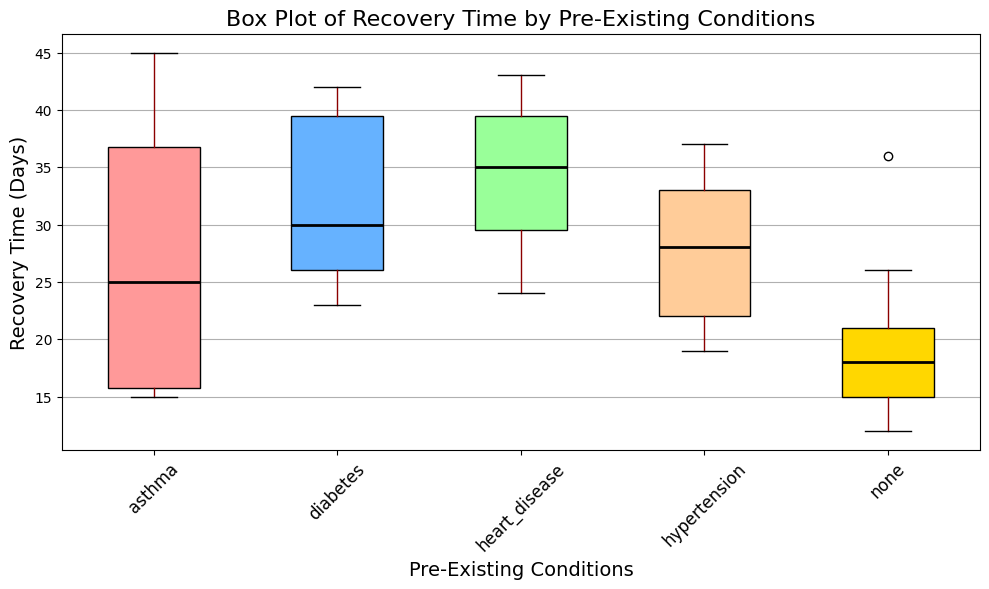What's the median recovery time for patients with diabetes? Look at the separate boxplot created for patients with diabetes and identify the median line inside the box. The median is where the line inside the box is drawn.
Answer: 30 Which pre-existing condition has the widest spread in recovery times? Compare the length of the boxes (interquartile ranges) and the range between the whiskers for each condition. The condition with the longest box or whiskers indicates the widest spread.
Answer: Asthma What is the difference between the maximum recovery times of patients with diabetes and heart disease? Identify the highest whisker for both diabetes and heart disease conditions. Subtract the maximum recovery time of heart disease from the maximum recovery time of diabetes.
Answer: 3 How does the recovery time for patients with hypertension compare to those with no pre-existing conditions? Visually compare the median lines and the range (spread) of the boxes for hypertension and no pre-existing conditions. Note whether one set of recovery times is higher or wider than the other.
Answer: Generally, hypertension patients have longer recovery times than those with no pre-existing conditions Which pre-existing condition has the shortest median recovery time? Look for the boxplot with the lowest median line. This is the horizontal line within each box.
Answer: None On average, do asthma patients have longer recovery times than those with hypertension? Compare the median lines for asthma and hypertension boxes. The median represents the average values for comparison.
Answer: Yes, asthma patients have longer recovery times than those with hypertension Are there any pre-existing conditions for which the recovery time exceeds 40 days? If yes, which ones? Look for any boxes or whiskers that extend beyond the 40-day mark. Identify the corresponding pre-existing conditions.
Answer: Yes, diabetes and asthma What is the interquartile range (IQR) for recovery times of patients with heart disease? Identify the bottom and top edges of the heart disease boxplot, which represent the first and third quartiles, respectively. Subtract the first quartile value from the third quartile value to find the IQR.
Answer: 10 